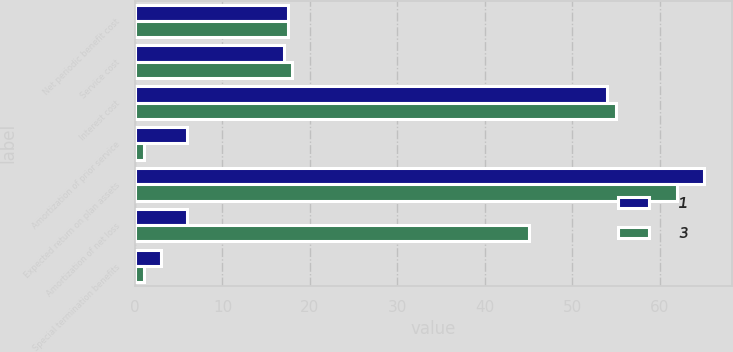<chart> <loc_0><loc_0><loc_500><loc_500><stacked_bar_chart><ecel><fcel>Net periodic benefit cost<fcel>Service cost<fcel>Interest cost<fcel>Amortization of prior service<fcel>Expected return on plan assets<fcel>Amortization of net loss<fcel>Special termination benefits<nl><fcel>1<fcel>17.5<fcel>17<fcel>54<fcel>6<fcel>65<fcel>6<fcel>3<nl><fcel>3<fcel>17.5<fcel>18<fcel>55<fcel>1<fcel>62<fcel>45<fcel>1<nl></chart> 